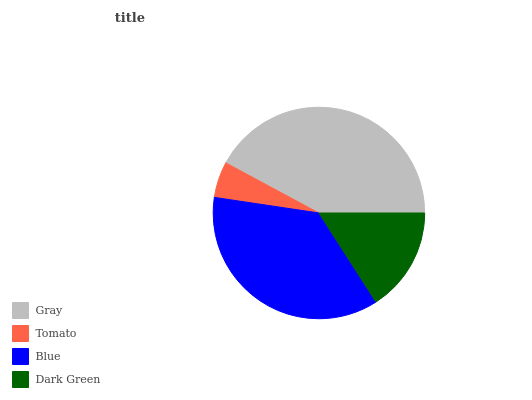Is Tomato the minimum?
Answer yes or no. Yes. Is Gray the maximum?
Answer yes or no. Yes. Is Blue the minimum?
Answer yes or no. No. Is Blue the maximum?
Answer yes or no. No. Is Blue greater than Tomato?
Answer yes or no. Yes. Is Tomato less than Blue?
Answer yes or no. Yes. Is Tomato greater than Blue?
Answer yes or no. No. Is Blue less than Tomato?
Answer yes or no. No. Is Blue the high median?
Answer yes or no. Yes. Is Dark Green the low median?
Answer yes or no. Yes. Is Tomato the high median?
Answer yes or no. No. Is Tomato the low median?
Answer yes or no. No. 